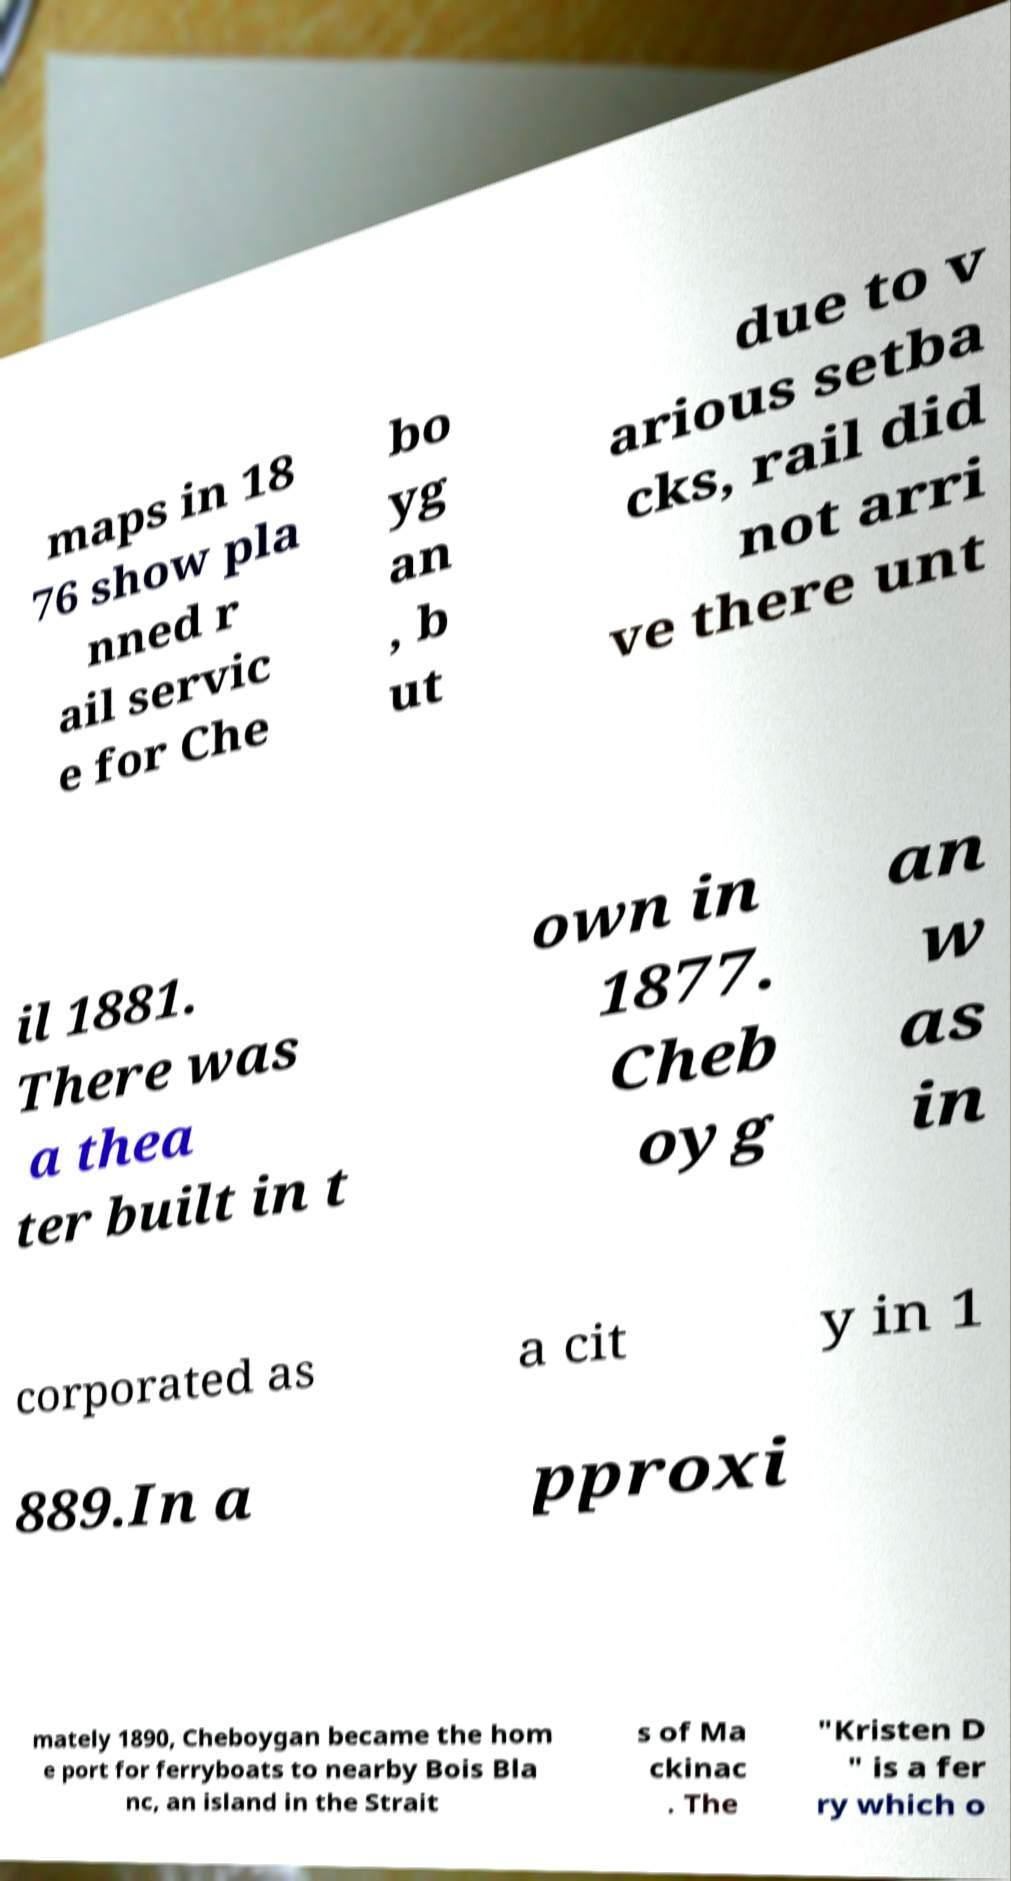Please identify and transcribe the text found in this image. maps in 18 76 show pla nned r ail servic e for Che bo yg an , b ut due to v arious setba cks, rail did not arri ve there unt il 1881. There was a thea ter built in t own in 1877. Cheb oyg an w as in corporated as a cit y in 1 889.In a pproxi mately 1890, Cheboygan became the hom e port for ferryboats to nearby Bois Bla nc, an island in the Strait s of Ma ckinac . The "Kristen D " is a fer ry which o 